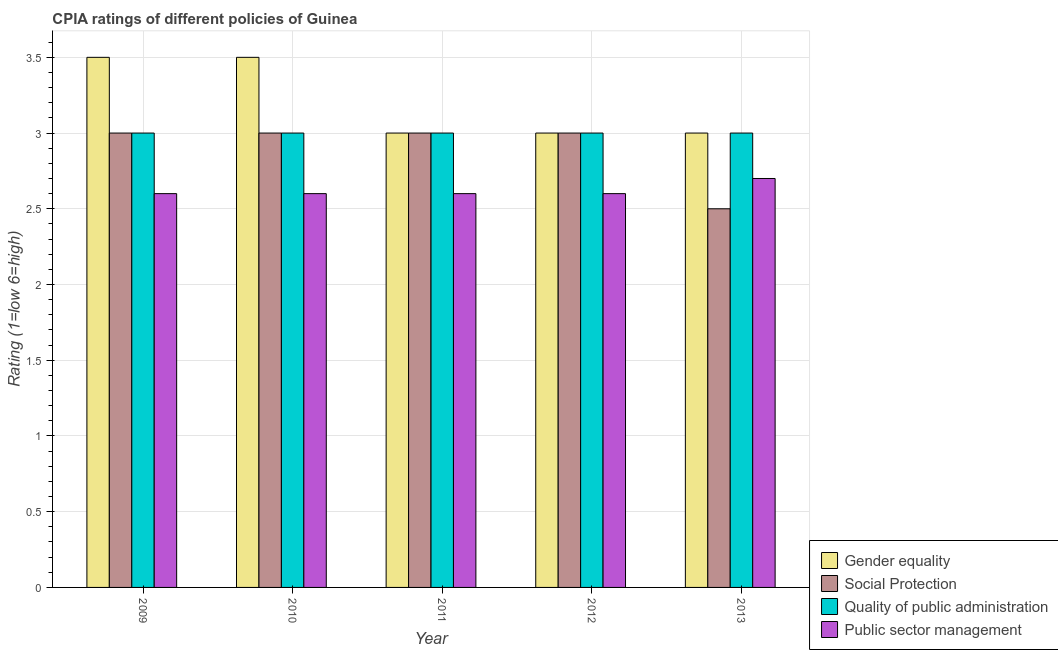Are the number of bars on each tick of the X-axis equal?
Provide a short and direct response. Yes. How many bars are there on the 4th tick from the left?
Make the answer very short. 4. How many bars are there on the 3rd tick from the right?
Provide a short and direct response. 4. Across all years, what is the maximum cpia rating of quality of public administration?
Ensure brevity in your answer.  3. Across all years, what is the minimum cpia rating of social protection?
Your answer should be compact. 2.5. In which year was the cpia rating of public sector management minimum?
Offer a terse response. 2009. What is the total cpia rating of quality of public administration in the graph?
Provide a succinct answer. 15. What is the difference between the cpia rating of public sector management in 2011 and that in 2013?
Offer a terse response. -0.1. What is the difference between the cpia rating of gender equality in 2013 and the cpia rating of social protection in 2010?
Keep it short and to the point. -0.5. In the year 2011, what is the difference between the cpia rating of gender equality and cpia rating of quality of public administration?
Make the answer very short. 0. Is the cpia rating of quality of public administration in 2010 less than that in 2013?
Your answer should be very brief. No. Is the difference between the cpia rating of social protection in 2009 and 2011 greater than the difference between the cpia rating of quality of public administration in 2009 and 2011?
Ensure brevity in your answer.  No. Is the sum of the cpia rating of public sector management in 2009 and 2010 greater than the maximum cpia rating of gender equality across all years?
Your answer should be compact. Yes. Is it the case that in every year, the sum of the cpia rating of gender equality and cpia rating of quality of public administration is greater than the sum of cpia rating of public sector management and cpia rating of social protection?
Your answer should be very brief. No. What does the 1st bar from the left in 2013 represents?
Your answer should be very brief. Gender equality. What does the 2nd bar from the right in 2012 represents?
Provide a short and direct response. Quality of public administration. Is it the case that in every year, the sum of the cpia rating of gender equality and cpia rating of social protection is greater than the cpia rating of quality of public administration?
Offer a terse response. Yes. How many bars are there?
Your answer should be very brief. 20. How many years are there in the graph?
Your answer should be compact. 5. Does the graph contain grids?
Ensure brevity in your answer.  Yes. Where does the legend appear in the graph?
Ensure brevity in your answer.  Bottom right. How many legend labels are there?
Give a very brief answer. 4. What is the title of the graph?
Provide a succinct answer. CPIA ratings of different policies of Guinea. What is the Rating (1=low 6=high) of Gender equality in 2009?
Provide a short and direct response. 3.5. What is the Rating (1=low 6=high) in Social Protection in 2009?
Provide a succinct answer. 3. What is the Rating (1=low 6=high) in Quality of public administration in 2009?
Ensure brevity in your answer.  3. What is the Rating (1=low 6=high) of Public sector management in 2009?
Your answer should be compact. 2.6. What is the Rating (1=low 6=high) in Gender equality in 2010?
Offer a terse response. 3.5. What is the Rating (1=low 6=high) in Quality of public administration in 2010?
Keep it short and to the point. 3. What is the Rating (1=low 6=high) of Gender equality in 2011?
Offer a very short reply. 3. What is the Rating (1=low 6=high) of Social Protection in 2011?
Your answer should be very brief. 3. What is the Rating (1=low 6=high) in Quality of public administration in 2012?
Offer a very short reply. 3. What is the Rating (1=low 6=high) of Public sector management in 2012?
Provide a succinct answer. 2.6. What is the Rating (1=low 6=high) of Gender equality in 2013?
Provide a short and direct response. 3. What is the Rating (1=low 6=high) of Social Protection in 2013?
Offer a very short reply. 2.5. What is the Rating (1=low 6=high) in Quality of public administration in 2013?
Ensure brevity in your answer.  3. Across all years, what is the maximum Rating (1=low 6=high) of Quality of public administration?
Ensure brevity in your answer.  3. Across all years, what is the minimum Rating (1=low 6=high) in Social Protection?
Your answer should be very brief. 2.5. Across all years, what is the minimum Rating (1=low 6=high) in Quality of public administration?
Offer a terse response. 3. Across all years, what is the minimum Rating (1=low 6=high) in Public sector management?
Provide a short and direct response. 2.6. What is the total Rating (1=low 6=high) in Gender equality in the graph?
Make the answer very short. 16. What is the total Rating (1=low 6=high) in Social Protection in the graph?
Provide a short and direct response. 14.5. What is the total Rating (1=low 6=high) of Public sector management in the graph?
Give a very brief answer. 13.1. What is the difference between the Rating (1=low 6=high) of Public sector management in 2009 and that in 2010?
Your answer should be compact. 0. What is the difference between the Rating (1=low 6=high) in Gender equality in 2009 and that in 2011?
Keep it short and to the point. 0.5. What is the difference between the Rating (1=low 6=high) in Social Protection in 2009 and that in 2011?
Make the answer very short. 0. What is the difference between the Rating (1=low 6=high) in Quality of public administration in 2009 and that in 2011?
Provide a succinct answer. 0. What is the difference between the Rating (1=low 6=high) in Gender equality in 2009 and that in 2012?
Your response must be concise. 0.5. What is the difference between the Rating (1=low 6=high) of Quality of public administration in 2009 and that in 2012?
Your response must be concise. 0. What is the difference between the Rating (1=low 6=high) in Public sector management in 2009 and that in 2012?
Offer a terse response. 0. What is the difference between the Rating (1=low 6=high) of Gender equality in 2009 and that in 2013?
Offer a very short reply. 0.5. What is the difference between the Rating (1=low 6=high) of Social Protection in 2009 and that in 2013?
Provide a succinct answer. 0.5. What is the difference between the Rating (1=low 6=high) of Gender equality in 2010 and that in 2011?
Provide a short and direct response. 0.5. What is the difference between the Rating (1=low 6=high) in Public sector management in 2010 and that in 2012?
Offer a terse response. 0. What is the difference between the Rating (1=low 6=high) in Quality of public administration in 2010 and that in 2013?
Your answer should be very brief. 0. What is the difference between the Rating (1=low 6=high) in Public sector management in 2010 and that in 2013?
Ensure brevity in your answer.  -0.1. What is the difference between the Rating (1=low 6=high) in Gender equality in 2011 and that in 2013?
Ensure brevity in your answer.  0. What is the difference between the Rating (1=low 6=high) of Social Protection in 2011 and that in 2013?
Provide a succinct answer. 0.5. What is the difference between the Rating (1=low 6=high) of Public sector management in 2011 and that in 2013?
Your answer should be very brief. -0.1. What is the difference between the Rating (1=low 6=high) of Gender equality in 2012 and that in 2013?
Provide a succinct answer. 0. What is the difference between the Rating (1=low 6=high) in Gender equality in 2009 and the Rating (1=low 6=high) in Social Protection in 2010?
Ensure brevity in your answer.  0.5. What is the difference between the Rating (1=low 6=high) of Gender equality in 2009 and the Rating (1=low 6=high) of Quality of public administration in 2010?
Give a very brief answer. 0.5. What is the difference between the Rating (1=low 6=high) of Gender equality in 2009 and the Rating (1=low 6=high) of Public sector management in 2010?
Provide a succinct answer. 0.9. What is the difference between the Rating (1=low 6=high) of Quality of public administration in 2009 and the Rating (1=low 6=high) of Public sector management in 2010?
Provide a short and direct response. 0.4. What is the difference between the Rating (1=low 6=high) in Gender equality in 2009 and the Rating (1=low 6=high) in Social Protection in 2011?
Keep it short and to the point. 0.5. What is the difference between the Rating (1=low 6=high) in Gender equality in 2009 and the Rating (1=low 6=high) in Quality of public administration in 2011?
Your response must be concise. 0.5. What is the difference between the Rating (1=low 6=high) in Gender equality in 2009 and the Rating (1=low 6=high) in Public sector management in 2011?
Make the answer very short. 0.9. What is the difference between the Rating (1=low 6=high) in Social Protection in 2009 and the Rating (1=low 6=high) in Quality of public administration in 2011?
Ensure brevity in your answer.  0. What is the difference between the Rating (1=low 6=high) of Social Protection in 2009 and the Rating (1=low 6=high) of Public sector management in 2011?
Offer a very short reply. 0.4. What is the difference between the Rating (1=low 6=high) in Quality of public administration in 2009 and the Rating (1=low 6=high) in Public sector management in 2011?
Provide a short and direct response. 0.4. What is the difference between the Rating (1=low 6=high) of Social Protection in 2009 and the Rating (1=low 6=high) of Public sector management in 2012?
Offer a very short reply. 0.4. What is the difference between the Rating (1=low 6=high) in Gender equality in 2009 and the Rating (1=low 6=high) in Social Protection in 2013?
Your answer should be compact. 1. What is the difference between the Rating (1=low 6=high) of Gender equality in 2009 and the Rating (1=low 6=high) of Public sector management in 2013?
Ensure brevity in your answer.  0.8. What is the difference between the Rating (1=low 6=high) in Social Protection in 2009 and the Rating (1=low 6=high) in Quality of public administration in 2013?
Provide a short and direct response. 0. What is the difference between the Rating (1=low 6=high) of Quality of public administration in 2009 and the Rating (1=low 6=high) of Public sector management in 2013?
Keep it short and to the point. 0.3. What is the difference between the Rating (1=low 6=high) of Social Protection in 2010 and the Rating (1=low 6=high) of Quality of public administration in 2011?
Provide a succinct answer. 0. What is the difference between the Rating (1=low 6=high) in Social Protection in 2010 and the Rating (1=low 6=high) in Public sector management in 2011?
Your answer should be very brief. 0.4. What is the difference between the Rating (1=low 6=high) in Social Protection in 2010 and the Rating (1=low 6=high) in Public sector management in 2012?
Ensure brevity in your answer.  0.4. What is the difference between the Rating (1=low 6=high) in Gender equality in 2010 and the Rating (1=low 6=high) in Quality of public administration in 2013?
Your answer should be compact. 0.5. What is the difference between the Rating (1=low 6=high) in Gender equality in 2010 and the Rating (1=low 6=high) in Public sector management in 2013?
Offer a very short reply. 0.8. What is the difference between the Rating (1=low 6=high) in Social Protection in 2010 and the Rating (1=low 6=high) in Quality of public administration in 2013?
Make the answer very short. 0. What is the difference between the Rating (1=low 6=high) in Gender equality in 2011 and the Rating (1=low 6=high) in Social Protection in 2012?
Keep it short and to the point. 0. What is the difference between the Rating (1=low 6=high) in Social Protection in 2011 and the Rating (1=low 6=high) in Quality of public administration in 2012?
Keep it short and to the point. 0. What is the difference between the Rating (1=low 6=high) of Gender equality in 2011 and the Rating (1=low 6=high) of Public sector management in 2013?
Your answer should be very brief. 0.3. What is the difference between the Rating (1=low 6=high) of Social Protection in 2011 and the Rating (1=low 6=high) of Quality of public administration in 2013?
Give a very brief answer. 0. What is the difference between the Rating (1=low 6=high) of Quality of public administration in 2011 and the Rating (1=low 6=high) of Public sector management in 2013?
Your response must be concise. 0.3. What is the difference between the Rating (1=low 6=high) in Gender equality in 2012 and the Rating (1=low 6=high) in Social Protection in 2013?
Make the answer very short. 0.5. What is the difference between the Rating (1=low 6=high) of Gender equality in 2012 and the Rating (1=low 6=high) of Quality of public administration in 2013?
Your response must be concise. 0. What is the difference between the Rating (1=low 6=high) of Social Protection in 2012 and the Rating (1=low 6=high) of Quality of public administration in 2013?
Ensure brevity in your answer.  0. What is the difference between the Rating (1=low 6=high) in Quality of public administration in 2012 and the Rating (1=low 6=high) in Public sector management in 2013?
Provide a succinct answer. 0.3. What is the average Rating (1=low 6=high) in Social Protection per year?
Your response must be concise. 2.9. What is the average Rating (1=low 6=high) of Quality of public administration per year?
Your answer should be very brief. 3. What is the average Rating (1=low 6=high) in Public sector management per year?
Your answer should be very brief. 2.62. In the year 2009, what is the difference between the Rating (1=low 6=high) in Social Protection and Rating (1=low 6=high) in Quality of public administration?
Your response must be concise. 0. In the year 2009, what is the difference between the Rating (1=low 6=high) in Quality of public administration and Rating (1=low 6=high) in Public sector management?
Offer a terse response. 0.4. In the year 2010, what is the difference between the Rating (1=low 6=high) in Gender equality and Rating (1=low 6=high) in Social Protection?
Provide a short and direct response. 0.5. In the year 2010, what is the difference between the Rating (1=low 6=high) of Gender equality and Rating (1=low 6=high) of Quality of public administration?
Keep it short and to the point. 0.5. In the year 2010, what is the difference between the Rating (1=low 6=high) of Gender equality and Rating (1=low 6=high) of Public sector management?
Your answer should be compact. 0.9. In the year 2010, what is the difference between the Rating (1=low 6=high) of Social Protection and Rating (1=low 6=high) of Public sector management?
Your answer should be compact. 0.4. In the year 2010, what is the difference between the Rating (1=low 6=high) of Quality of public administration and Rating (1=low 6=high) of Public sector management?
Ensure brevity in your answer.  0.4. In the year 2011, what is the difference between the Rating (1=low 6=high) in Gender equality and Rating (1=low 6=high) in Public sector management?
Offer a terse response. 0.4. In the year 2011, what is the difference between the Rating (1=low 6=high) of Quality of public administration and Rating (1=low 6=high) of Public sector management?
Provide a succinct answer. 0.4. In the year 2012, what is the difference between the Rating (1=low 6=high) in Gender equality and Rating (1=low 6=high) in Quality of public administration?
Offer a very short reply. 0. In the year 2012, what is the difference between the Rating (1=low 6=high) in Gender equality and Rating (1=low 6=high) in Public sector management?
Ensure brevity in your answer.  0.4. In the year 2012, what is the difference between the Rating (1=low 6=high) of Social Protection and Rating (1=low 6=high) of Public sector management?
Provide a succinct answer. 0.4. In the year 2013, what is the difference between the Rating (1=low 6=high) in Gender equality and Rating (1=low 6=high) in Social Protection?
Give a very brief answer. 0.5. In the year 2013, what is the difference between the Rating (1=low 6=high) of Social Protection and Rating (1=low 6=high) of Quality of public administration?
Make the answer very short. -0.5. In the year 2013, what is the difference between the Rating (1=low 6=high) in Social Protection and Rating (1=low 6=high) in Public sector management?
Your answer should be compact. -0.2. In the year 2013, what is the difference between the Rating (1=low 6=high) of Quality of public administration and Rating (1=low 6=high) of Public sector management?
Your response must be concise. 0.3. What is the ratio of the Rating (1=low 6=high) in Gender equality in 2009 to that in 2010?
Make the answer very short. 1. What is the ratio of the Rating (1=low 6=high) in Social Protection in 2009 to that in 2010?
Your answer should be compact. 1. What is the ratio of the Rating (1=low 6=high) in Quality of public administration in 2009 to that in 2010?
Provide a short and direct response. 1. What is the ratio of the Rating (1=low 6=high) of Gender equality in 2009 to that in 2011?
Provide a succinct answer. 1.17. What is the ratio of the Rating (1=low 6=high) in Social Protection in 2009 to that in 2011?
Keep it short and to the point. 1. What is the ratio of the Rating (1=low 6=high) in Public sector management in 2009 to that in 2011?
Offer a very short reply. 1. What is the ratio of the Rating (1=low 6=high) of Gender equality in 2009 to that in 2012?
Your response must be concise. 1.17. What is the ratio of the Rating (1=low 6=high) of Social Protection in 2009 to that in 2012?
Offer a very short reply. 1. What is the ratio of the Rating (1=low 6=high) in Gender equality in 2009 to that in 2013?
Offer a very short reply. 1.17. What is the ratio of the Rating (1=low 6=high) in Social Protection in 2009 to that in 2013?
Make the answer very short. 1.2. What is the ratio of the Rating (1=low 6=high) in Quality of public administration in 2009 to that in 2013?
Your response must be concise. 1. What is the ratio of the Rating (1=low 6=high) of Public sector management in 2009 to that in 2013?
Make the answer very short. 0.96. What is the ratio of the Rating (1=low 6=high) in Gender equality in 2010 to that in 2011?
Provide a succinct answer. 1.17. What is the ratio of the Rating (1=low 6=high) in Social Protection in 2010 to that in 2011?
Give a very brief answer. 1. What is the ratio of the Rating (1=low 6=high) of Gender equality in 2010 to that in 2012?
Your answer should be compact. 1.17. What is the ratio of the Rating (1=low 6=high) in Social Protection in 2010 to that in 2012?
Your answer should be very brief. 1. What is the ratio of the Rating (1=low 6=high) of Quality of public administration in 2010 to that in 2012?
Offer a very short reply. 1. What is the ratio of the Rating (1=low 6=high) of Public sector management in 2010 to that in 2012?
Offer a terse response. 1. What is the ratio of the Rating (1=low 6=high) in Gender equality in 2011 to that in 2012?
Your answer should be very brief. 1. What is the ratio of the Rating (1=low 6=high) of Social Protection in 2011 to that in 2012?
Provide a short and direct response. 1. What is the ratio of the Rating (1=low 6=high) of Public sector management in 2011 to that in 2012?
Make the answer very short. 1. What is the ratio of the Rating (1=low 6=high) of Gender equality in 2011 to that in 2013?
Offer a terse response. 1. What is the ratio of the Rating (1=low 6=high) of Quality of public administration in 2011 to that in 2013?
Provide a succinct answer. 1. What is the ratio of the Rating (1=low 6=high) of Social Protection in 2012 to that in 2013?
Your answer should be compact. 1.2. What is the ratio of the Rating (1=low 6=high) of Quality of public administration in 2012 to that in 2013?
Keep it short and to the point. 1. What is the difference between the highest and the second highest Rating (1=low 6=high) of Gender equality?
Your response must be concise. 0. What is the difference between the highest and the second highest Rating (1=low 6=high) of Social Protection?
Provide a succinct answer. 0. 